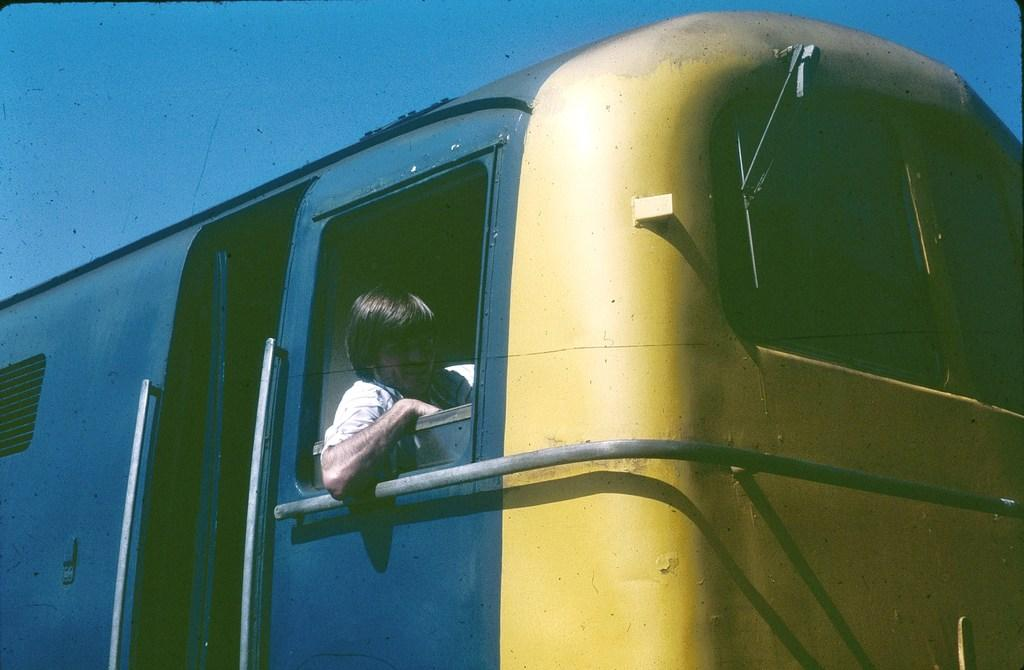What is the main subject of the image? There is a person in the image. What is the person doing in the image? The person is sitting in a motor vehicle. What type of desk can be seen in the image? There is no desk present in the image; it features a person sitting in a motor vehicle. What is the person's interest in the image? The image does not provide information about the person's interests. 